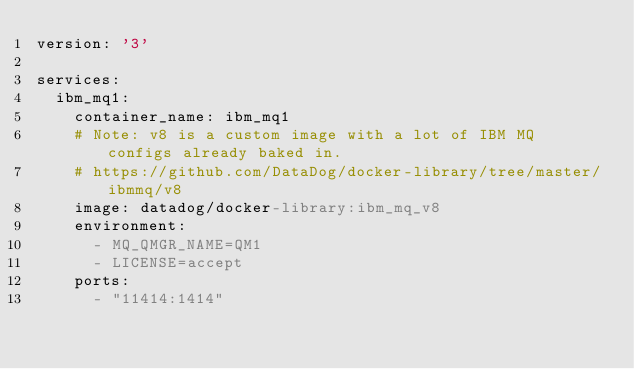Convert code to text. <code><loc_0><loc_0><loc_500><loc_500><_YAML_>version: '3'

services:
  ibm_mq1:
    container_name: ibm_mq1
    # Note: v8 is a custom image with a lot of IBM MQ configs already baked in.
    # https://github.com/DataDog/docker-library/tree/master/ibmmq/v8
    image: datadog/docker-library:ibm_mq_v8
    environment:
      - MQ_QMGR_NAME=QM1
      - LICENSE=accept
    ports:
      - "11414:1414"
</code> 